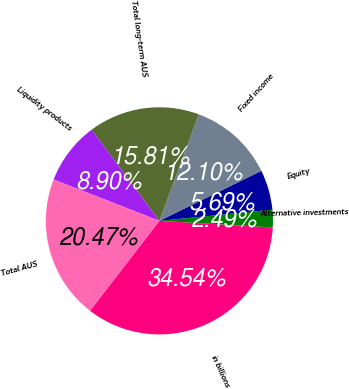Convert chart to OTSL. <chart><loc_0><loc_0><loc_500><loc_500><pie_chart><fcel>in billions<fcel>Alternative investments<fcel>Equity<fcel>Fixed income<fcel>Total long-term AUS<fcel>Liquidity products<fcel>Total AUS<nl><fcel>34.54%<fcel>2.49%<fcel>5.69%<fcel>12.1%<fcel>15.81%<fcel>8.9%<fcel>20.47%<nl></chart> 